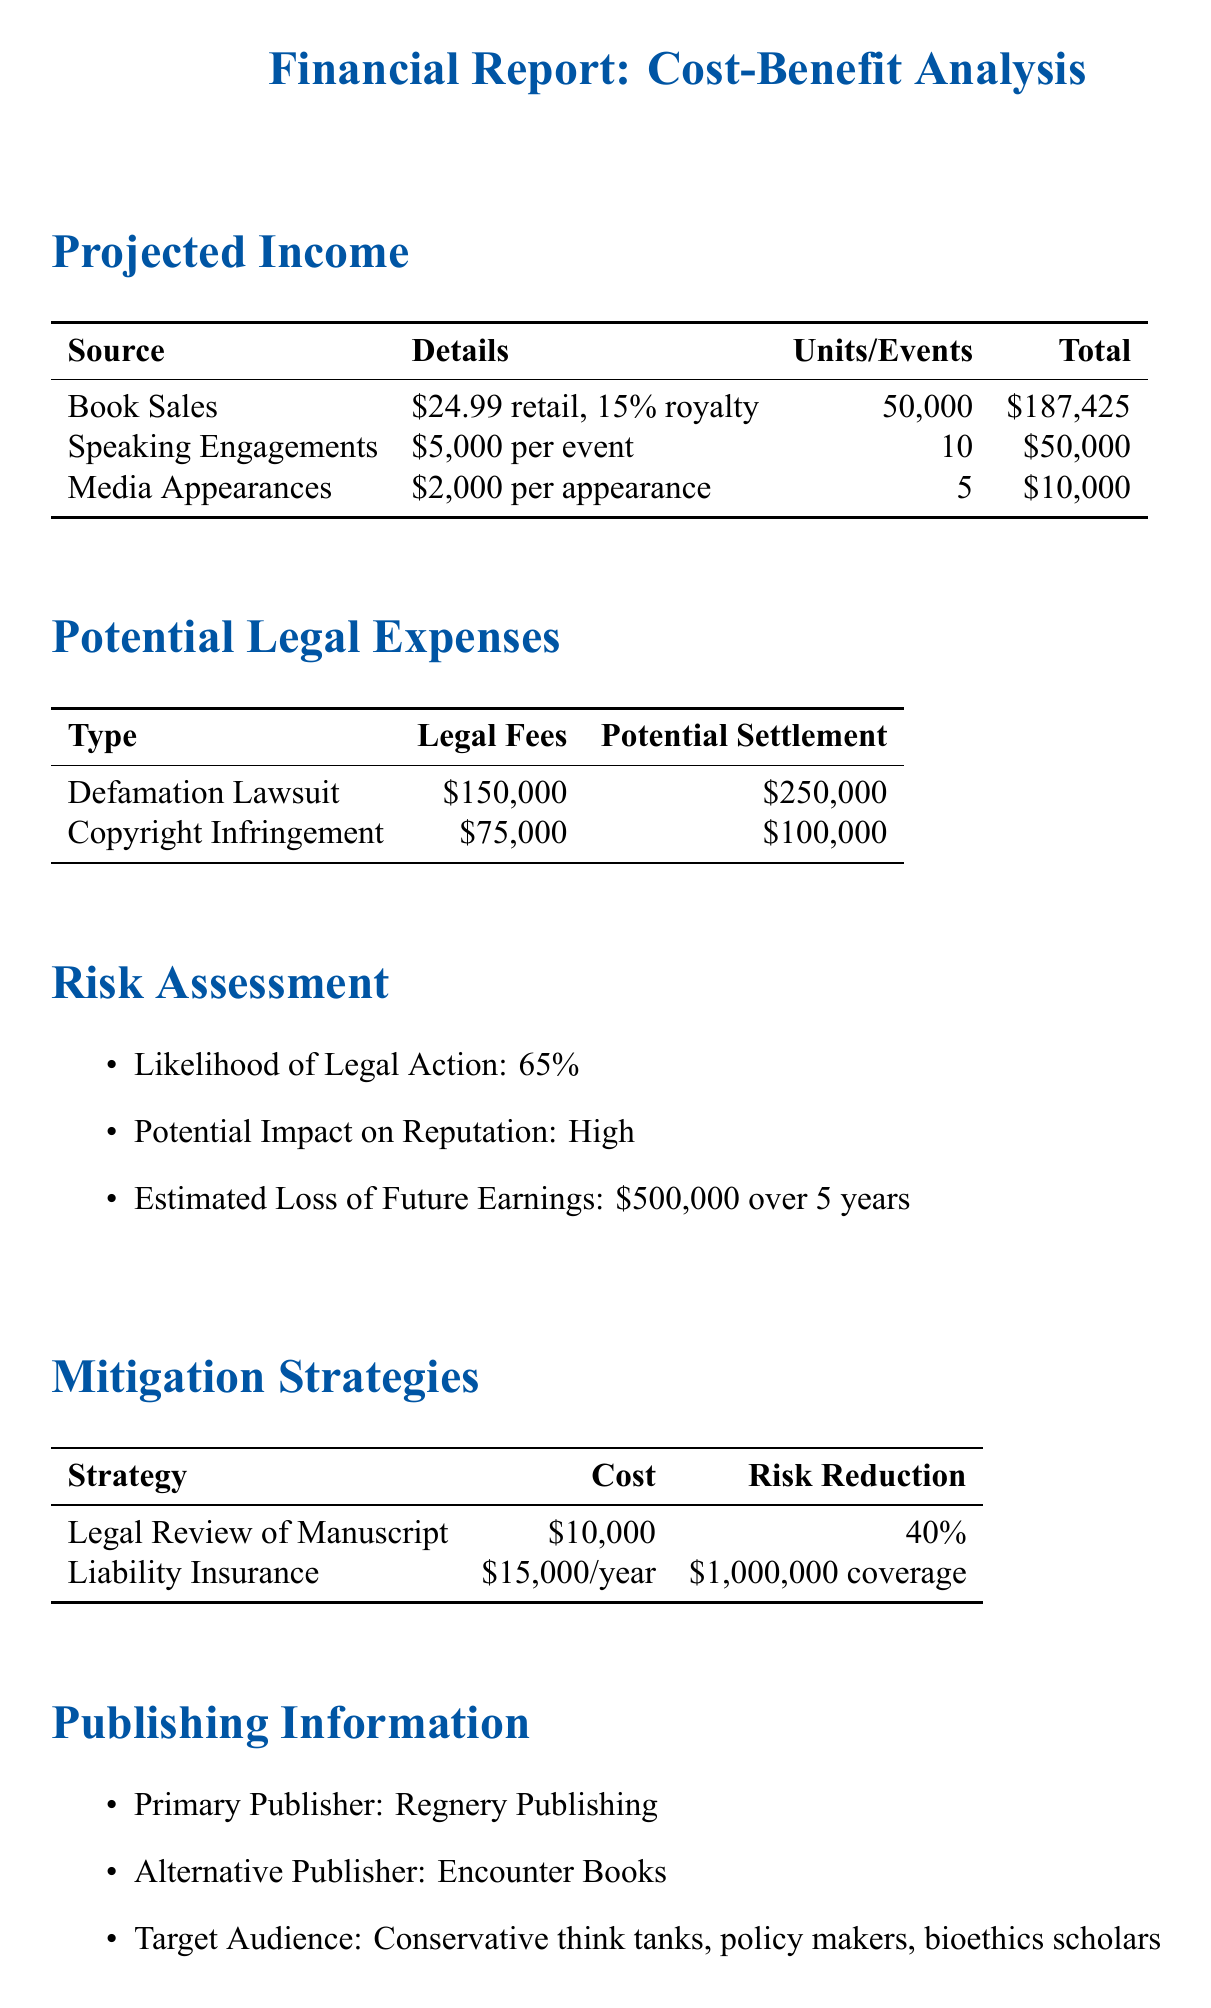What is the total projected income from book sales? The total projected income from book sales is stated in the document, which is $187,425.
Answer: $187,425 What are the estimated legal fees for the defamation lawsuit? The estimated legal fees for the defamation lawsuit are provided in the document as $150,000.
Answer: $150,000 What percentage of risk reduction does the legal review of the manuscript provide? The document states that the legal review of the manuscript provides a risk reduction of 40%.
Answer: 40% What is the likelihood of legal action? This information is mentioned in the risk assessment section of the document as 65%.
Answer: 65% What is the annual premium for liability insurance? The annual premium for liability insurance is specified as $15,000 in the mitigation strategies section.
Answer: $15,000 What is the potential impact on reputation? The document describes the potential impact on reputation as high.
Answer: High How many speaking engagements are projected? The number of projected speaking engagements is detailed in the income section as 10.
Answer: 10 Who is the primary publisher mentioned? The primary publisher is listed in the publishing information section as Regnery Publishing.
Answer: Regnery Publishing 